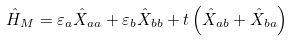<formula> <loc_0><loc_0><loc_500><loc_500>\hat { H } _ { M } = \varepsilon _ { a } \hat { X } _ { a a } + \varepsilon _ { b } \hat { X } _ { b b } + t \left ( \hat { X } _ { a b } + \hat { X } _ { b a } \right )</formula> 